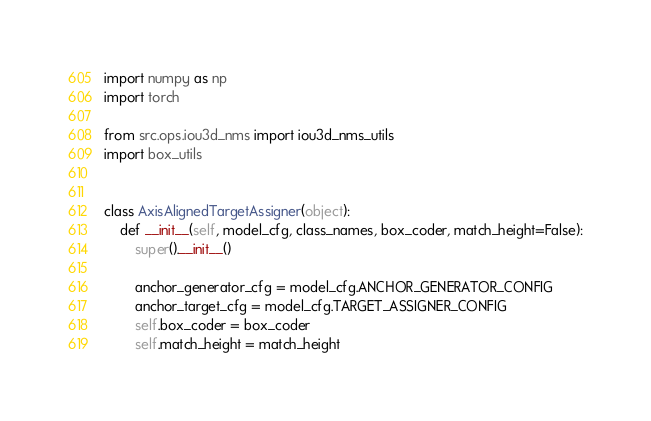Convert code to text. <code><loc_0><loc_0><loc_500><loc_500><_Python_>import numpy as np
import torch

from src.ops.iou3d_nms import iou3d_nms_utils
import box_utils


class AxisAlignedTargetAssigner(object):
    def __init__(self, model_cfg, class_names, box_coder, match_height=False):
        super().__init__()

        anchor_generator_cfg = model_cfg.ANCHOR_GENERATOR_CONFIG
        anchor_target_cfg = model_cfg.TARGET_ASSIGNER_CONFIG
        self.box_coder = box_coder
        self.match_height = match_height</code> 